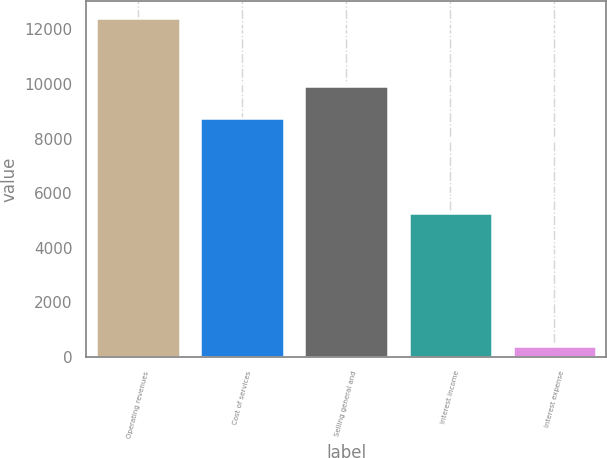Convert chart to OTSL. <chart><loc_0><loc_0><loc_500><loc_500><bar_chart><fcel>Operating revenues<fcel>Cost of services<fcel>Selling general and<fcel>Interest income<fcel>Interest expense<nl><fcel>12413<fcel>8740<fcel>9939.6<fcel>5267<fcel>417<nl></chart> 